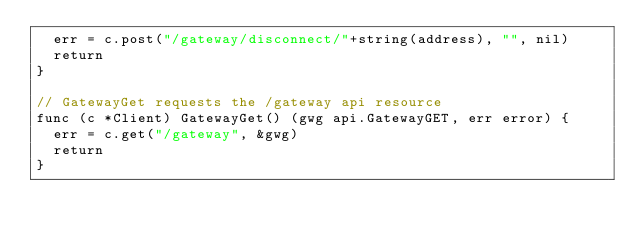<code> <loc_0><loc_0><loc_500><loc_500><_Go_>	err = c.post("/gateway/disconnect/"+string(address), "", nil)
	return
}

// GatewayGet requests the /gateway api resource
func (c *Client) GatewayGet() (gwg api.GatewayGET, err error) {
	err = c.get("/gateway", &gwg)
	return
}
</code> 